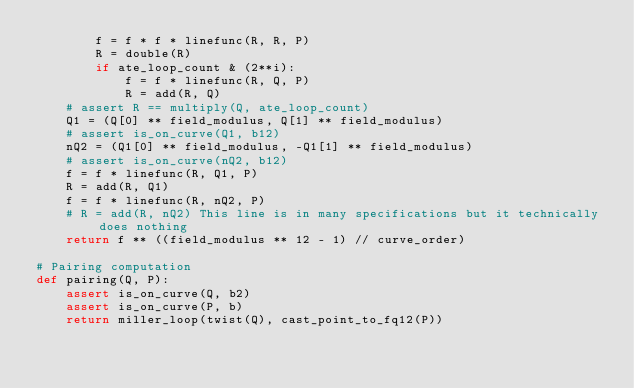Convert code to text. <code><loc_0><loc_0><loc_500><loc_500><_Python_>        f = f * f * linefunc(R, R, P)
        R = double(R)
        if ate_loop_count & (2**i):
            f = f * linefunc(R, Q, P)
            R = add(R, Q)
    # assert R == multiply(Q, ate_loop_count)
    Q1 = (Q[0] ** field_modulus, Q[1] ** field_modulus)
    # assert is_on_curve(Q1, b12)
    nQ2 = (Q1[0] ** field_modulus, -Q1[1] ** field_modulus)
    # assert is_on_curve(nQ2, b12)
    f = f * linefunc(R, Q1, P)
    R = add(R, Q1)
    f = f * linefunc(R, nQ2, P)
    # R = add(R, nQ2) This line is in many specifications but it technically does nothing
    return f ** ((field_modulus ** 12 - 1) // curve_order)

# Pairing computation
def pairing(Q, P):
    assert is_on_curve(Q, b2)
    assert is_on_curve(P, b)
    return miller_loop(twist(Q), cast_point_to_fq12(P))
</code> 